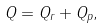Convert formula to latex. <formula><loc_0><loc_0><loc_500><loc_500>Q = Q _ { r } + Q _ { p } ,</formula> 